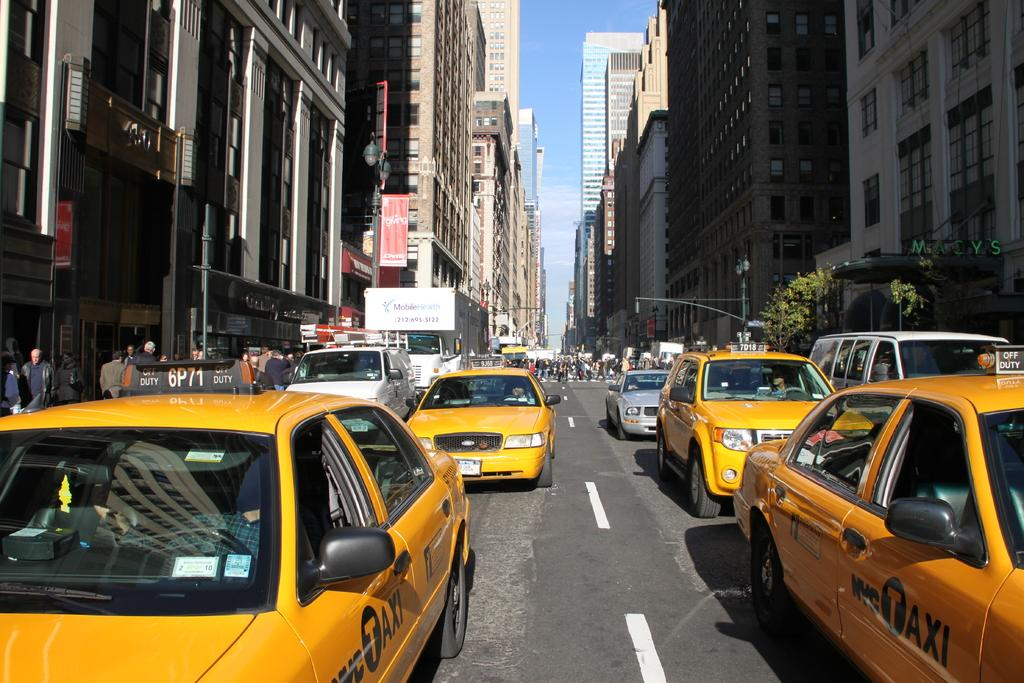<image>
Relay a brief, clear account of the picture shown. Number 10 can be seen on the white sign on the window of the yellow taxi to the left. 